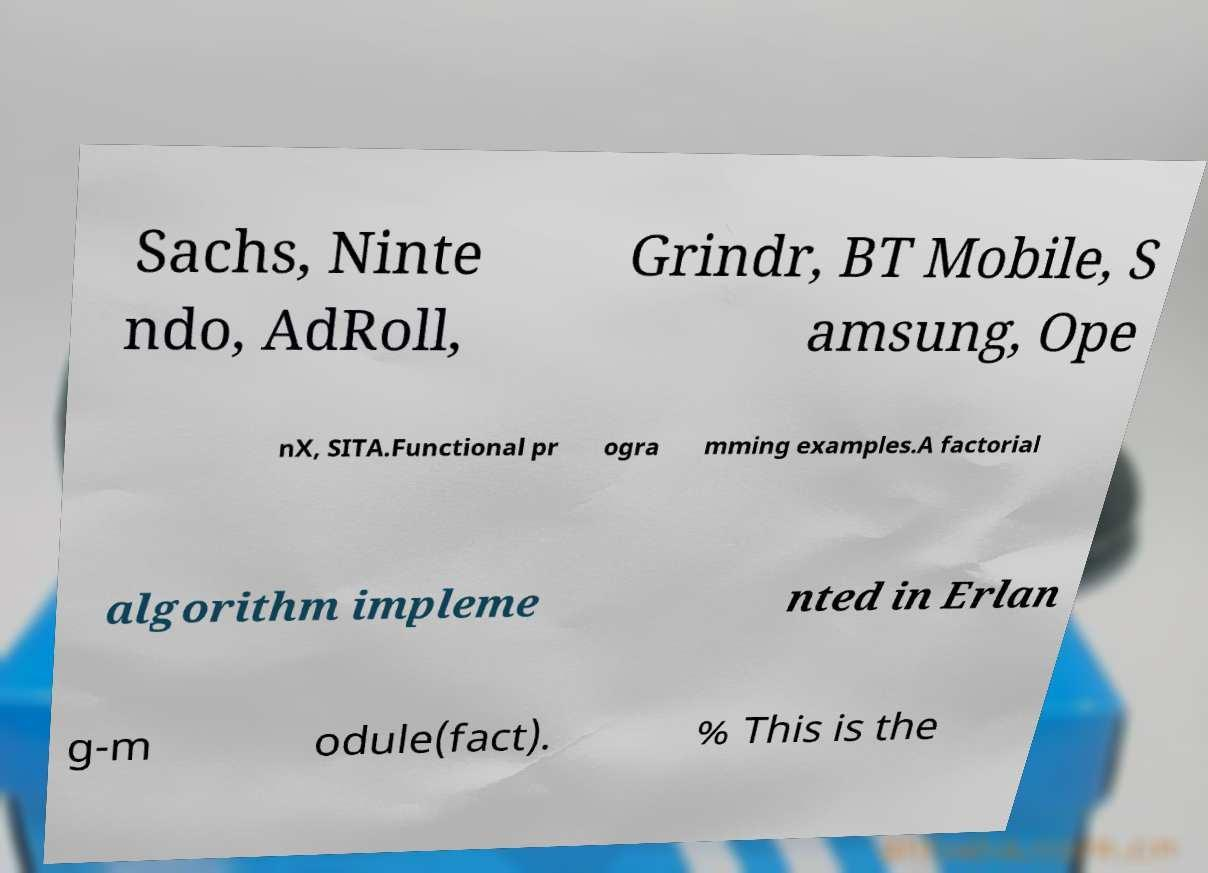What messages or text are displayed in this image? I need them in a readable, typed format. Sachs, Ninte ndo, AdRoll, Grindr, BT Mobile, S amsung, Ope nX, SITA.Functional pr ogra mming examples.A factorial algorithm impleme nted in Erlan g-m odule(fact). % This is the 